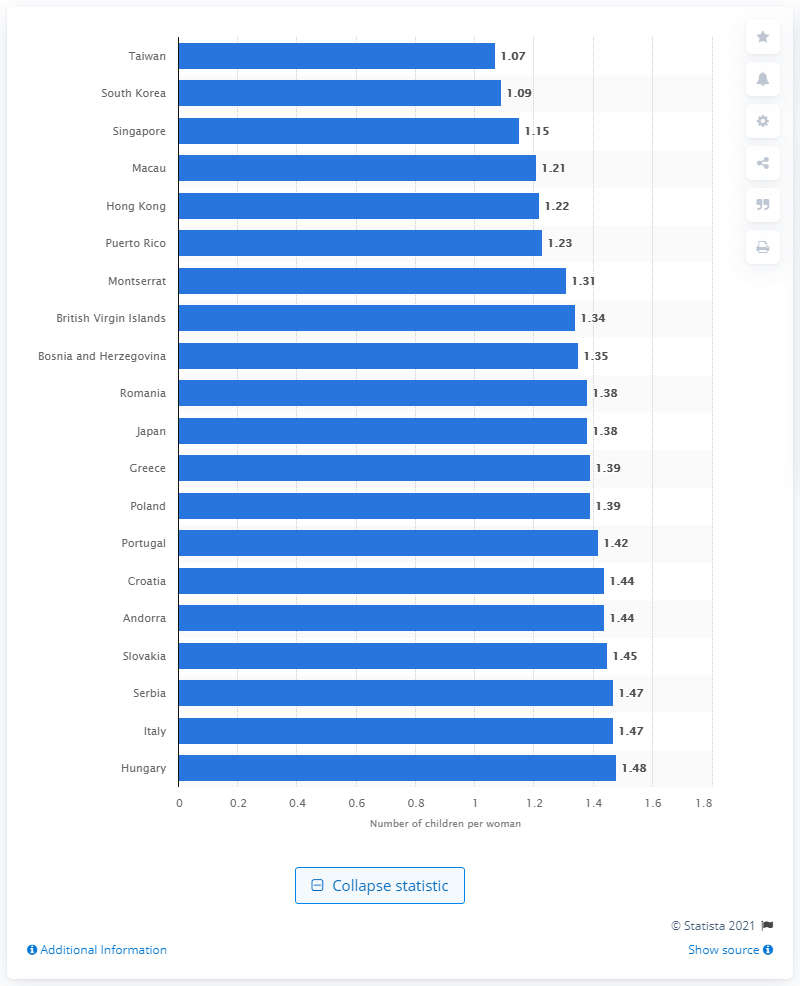List a handful of essential elements in this visual. In 2021, the fertility rate in Taiwan was 1.07. 